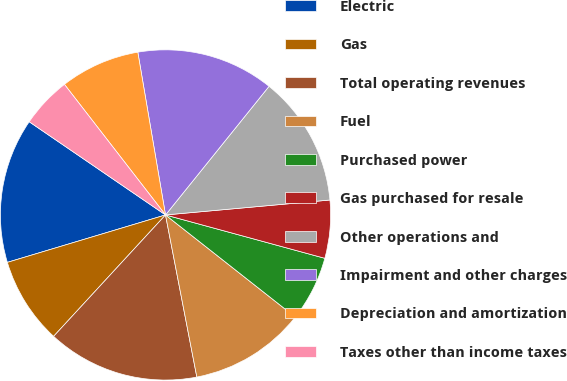Convert chart. <chart><loc_0><loc_0><loc_500><loc_500><pie_chart><fcel>Electric<fcel>Gas<fcel>Total operating revenues<fcel>Fuel<fcel>Purchased power<fcel>Gas purchased for resale<fcel>Other operations and<fcel>Impairment and other charges<fcel>Depreciation and amortization<fcel>Taxes other than income taxes<nl><fcel>14.18%<fcel>8.51%<fcel>14.89%<fcel>11.35%<fcel>6.38%<fcel>5.67%<fcel>12.77%<fcel>13.47%<fcel>7.8%<fcel>4.97%<nl></chart> 